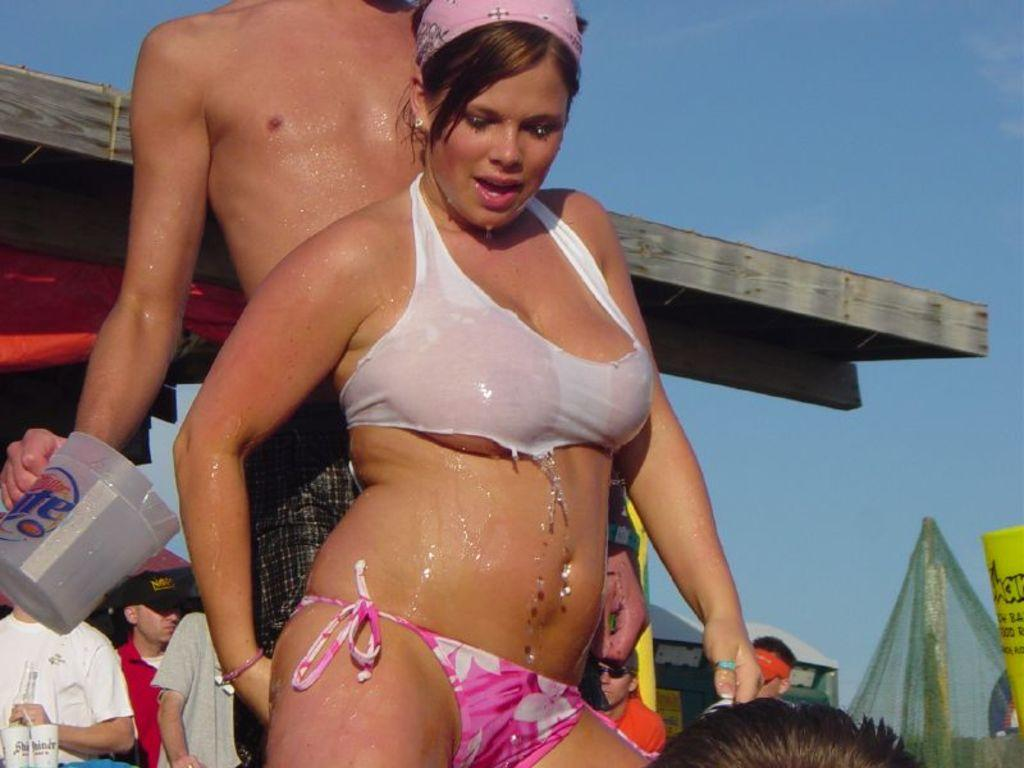Who is the main subject in the front of the image? There is a woman standing in the front of the image. Who is positioned behind the woman? There is a man standing behind the woman. What can be seen in the background of the image? There are persons and a tent visible in the background of the image. What type of structure is visible in the background of the image? There is a roof visible in the background of the image. What type of activity is the goldfish participating in within the image? There is no goldfish present in the image, so it cannot be participating in any activity. 